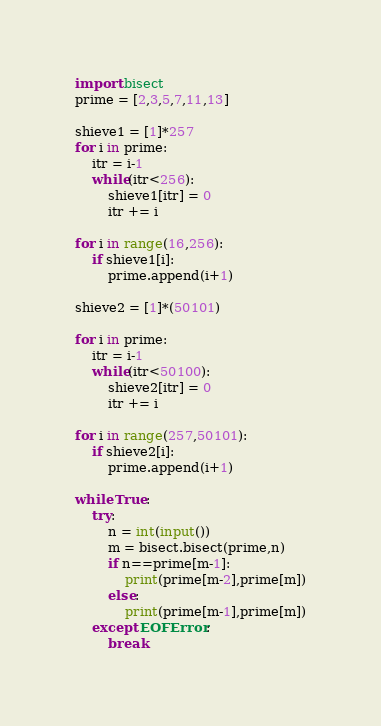<code> <loc_0><loc_0><loc_500><loc_500><_Python_>import bisect
prime = [2,3,5,7,11,13]

shieve1 = [1]*257
for i in prime:
    itr = i-1
    while(itr<256):
        shieve1[itr] = 0
        itr += i

for i in range(16,256):
    if shieve1[i]:
        prime.append(i+1)

shieve2 = [1]*(50101)

for i in prime:
    itr = i-1
    while(itr<50100):
        shieve2[itr] = 0
        itr += i

for i in range(257,50101):
    if shieve2[i]:
        prime.append(i+1)

while True:
    try:
        n = int(input())
        m = bisect.bisect(prime,n)
        if n==prime[m-1]:
            print(prime[m-2],prime[m])
        else:
            print(prime[m-1],prime[m])
    except EOFError:
        break</code> 